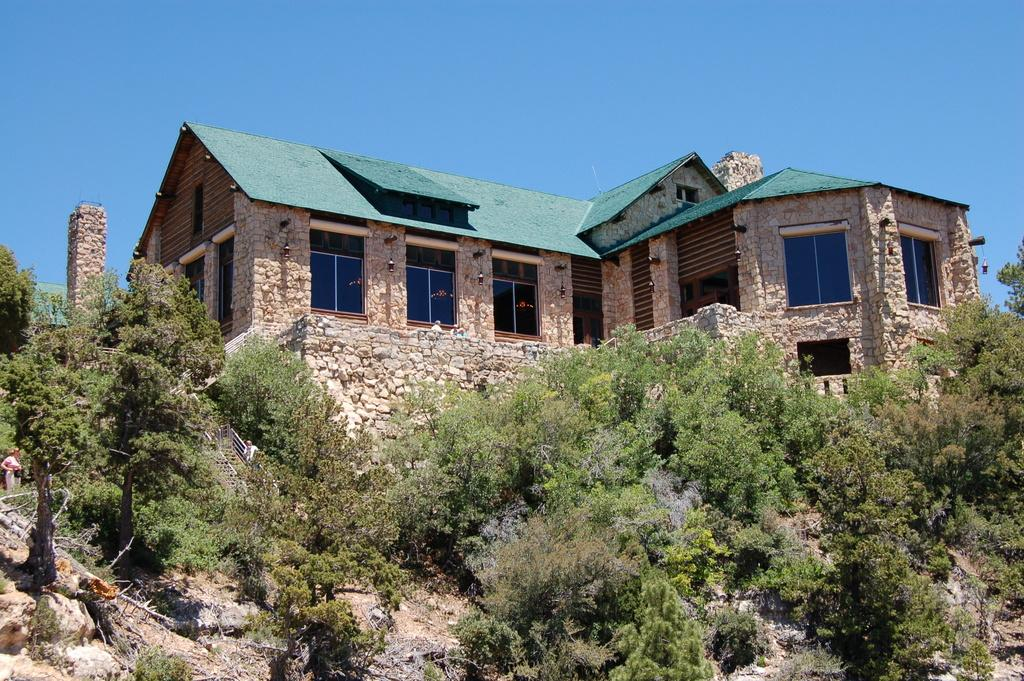What type of vegetation can be seen in the image? There are trees in the image. What color are the trees? The trees are green. What structure is visible in the background of the image? There is a house in the background of the image. What color is the house? The house is brown. What type of windows can be seen in the image? There are glass windows visible in the image. What color is the sky in the image? The sky is blue. How does the journey of the cough relate to the boundary in the image? There is no journey, cough, or boundary present in the image; it features trees, a brown house, glass windows, and a blue sky. 